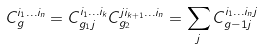Convert formula to latex. <formula><loc_0><loc_0><loc_500><loc_500>C _ { g } ^ { i _ { 1 } \dots i _ { n } } = C _ { g _ { 1 } j } ^ { i _ { 1 } \dots i _ { k } } C _ { g _ { 2 } } ^ { j i _ { k + 1 } \dots i _ { n } } = \sum _ { j } C _ { g - 1 j } ^ { i _ { 1 } \dots i _ { n } j }</formula> 